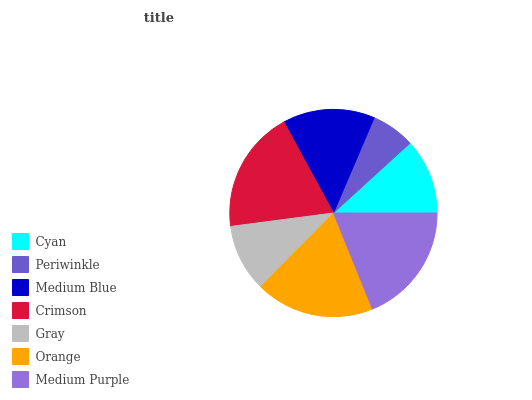Is Periwinkle the minimum?
Answer yes or no. Yes. Is Crimson the maximum?
Answer yes or no. Yes. Is Medium Blue the minimum?
Answer yes or no. No. Is Medium Blue the maximum?
Answer yes or no. No. Is Medium Blue greater than Periwinkle?
Answer yes or no. Yes. Is Periwinkle less than Medium Blue?
Answer yes or no. Yes. Is Periwinkle greater than Medium Blue?
Answer yes or no. No. Is Medium Blue less than Periwinkle?
Answer yes or no. No. Is Medium Blue the high median?
Answer yes or no. Yes. Is Medium Blue the low median?
Answer yes or no. Yes. Is Orange the high median?
Answer yes or no. No. Is Gray the low median?
Answer yes or no. No. 